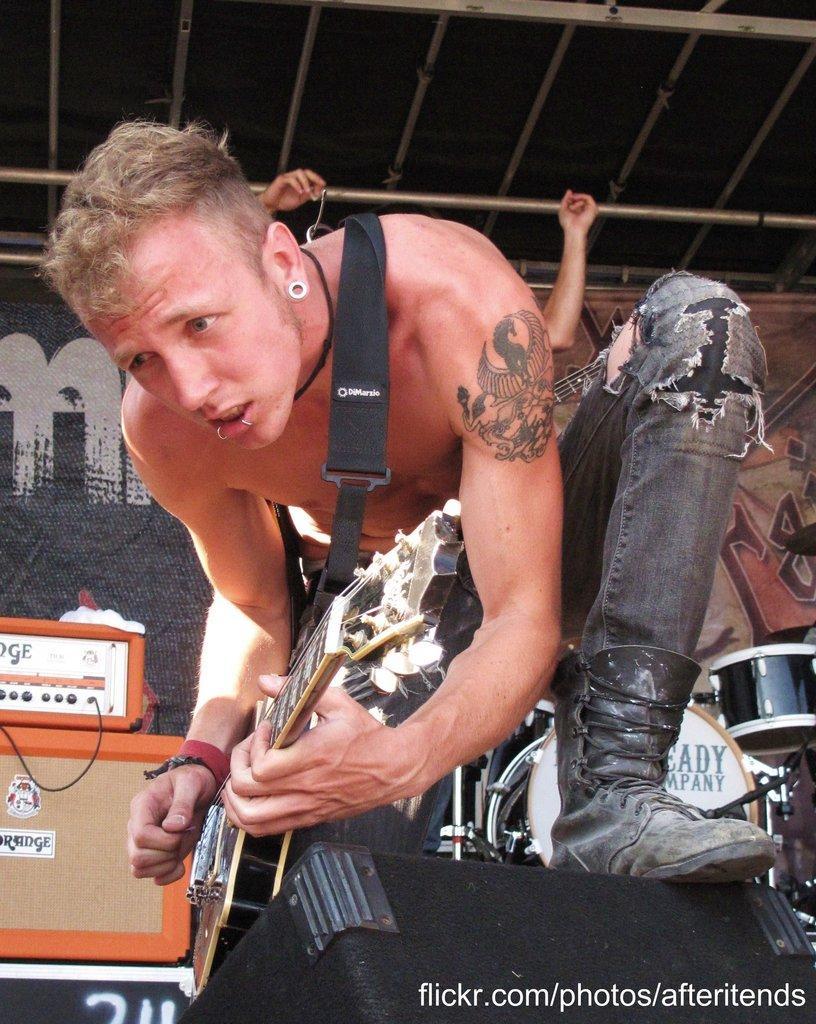In one or two sentences, can you explain what this image depicts? This picture shows a man kneeling and playing a guitar. 